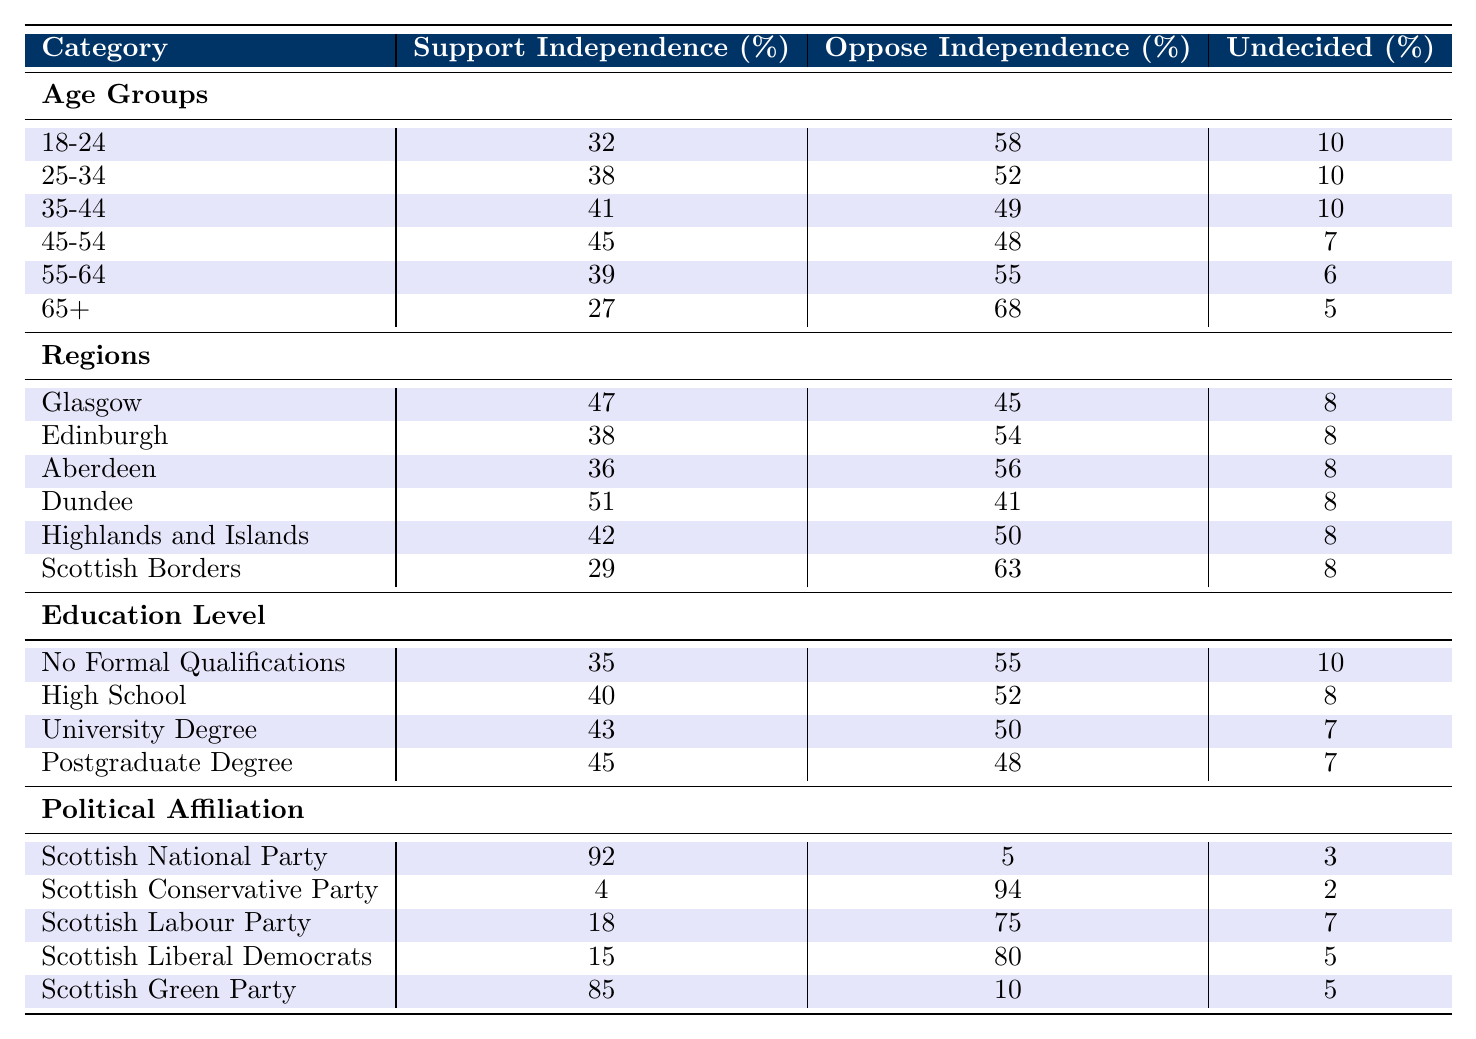What is the percentage of people aged 18-24 who oppose Scottish independence? From the table under the "Age Groups" section, the value for "Oppose Independence" for the 18-24 age group is 58%.
Answer: 58% What percentage of respondents from Edinburgh support independence? Looking at the "Regions" section, the "Support Independence" value for Edinburgh is 38%.
Answer: 38% Which age group has the highest percentage of opposition to independence? By examining the "Age Groups" section, the highest opposition percentage is from the 65+ age group at 68%.
Answer: 65+ Calculate the average support for independence across all age groups. The support percentages for age groups are 32, 38, 41, 45, 39, and 27. Summing these values gives 222, and dividing by 6 (number of groups) results in an average of 37.
Answer: 37 Is the support for independence higher among the Scottish National Party affiliates compared to the Scottish Conservative Party affiliates? According to the "Political Affiliation" section, support is 92% for the Scottish National Party and 4% for the Scottish Conservative Party. Therefore, yes, it is higher among SNP affiliates.
Answer: Yes What is the difference in the percentage of support for independence between those with a university degree and those with no formal qualifications? The support for independence among those with a university degree is 43%, and for those with no formal qualifications, it is 35%. The difference is 43 - 35 = 8.
Answer: 8% Which region shows the least support for independence? From the "Regions" section, the Scottish Borders has the lowest support at 29%.
Answer: Scottish Borders For the 45-54 age group, how many more people oppose independence compared to those who support it? The "Oppose Independence" for the 45-54 age group is 48%, and "Support Independence" is 45%. The difference is 48 - 45 = 3%.
Answer: 3% Is there an age group where the percentage of undecided voters is greater than those who support independence? In the 18-24 age group, 10% are undecided, which is greater than 32% supporting independence. Thus, yes, this is true for that age group.
Answer: Yes 